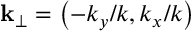<formula> <loc_0><loc_0><loc_500><loc_500>k _ { \perp } = \left ( - k _ { y } / k , k _ { x } / k \right )</formula> 